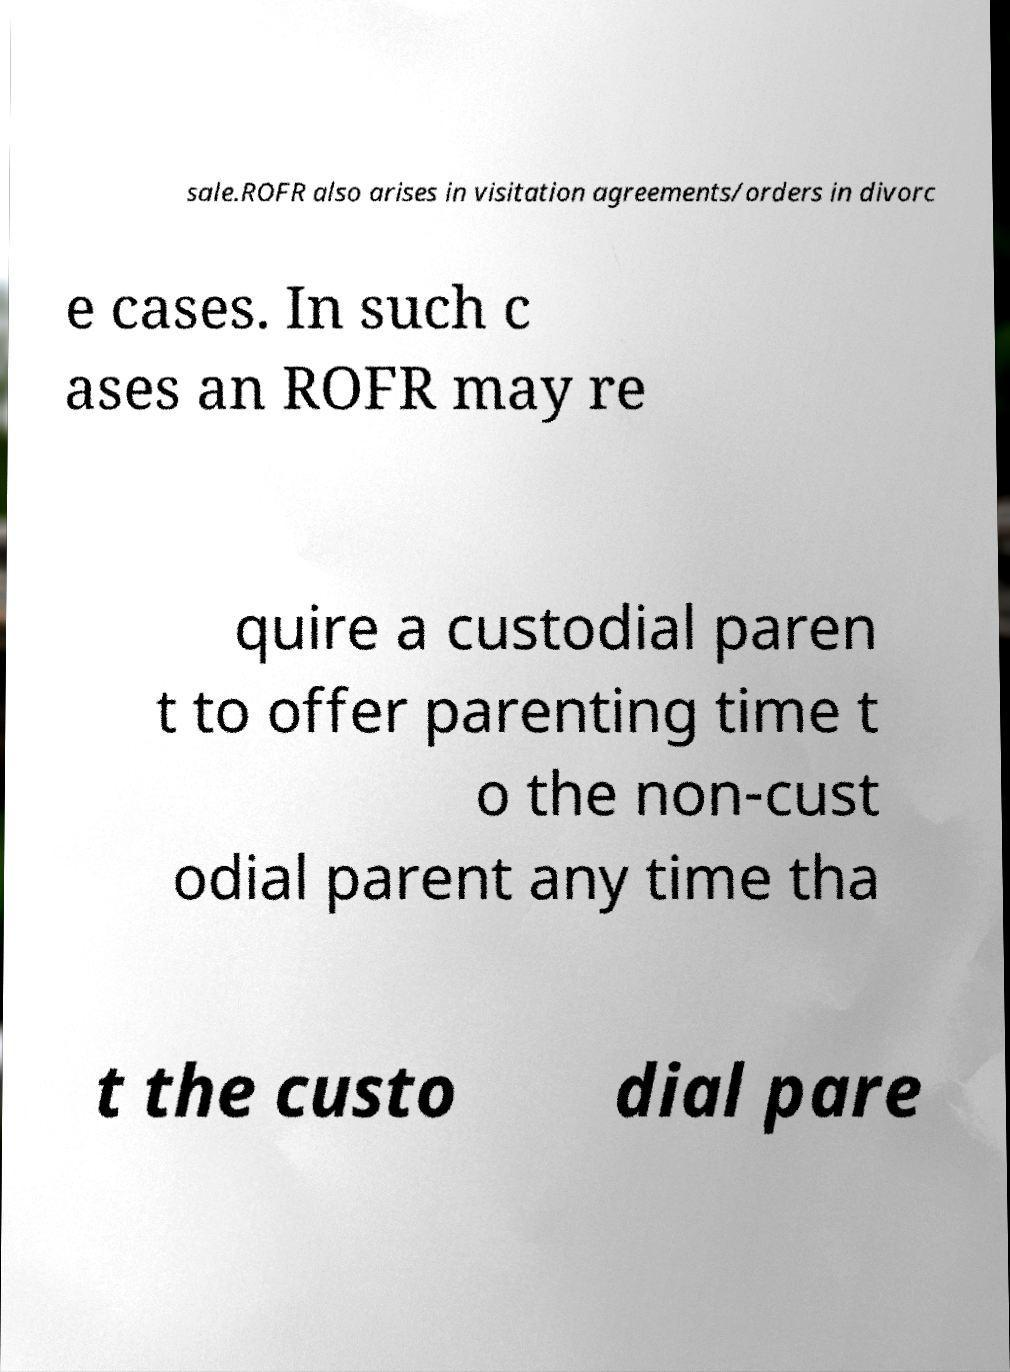Please read and relay the text visible in this image. What does it say? sale.ROFR also arises in visitation agreements/orders in divorc e cases. In such c ases an ROFR may re quire a custodial paren t to offer parenting time t o the non-cust odial parent any time tha t the custo dial pare 